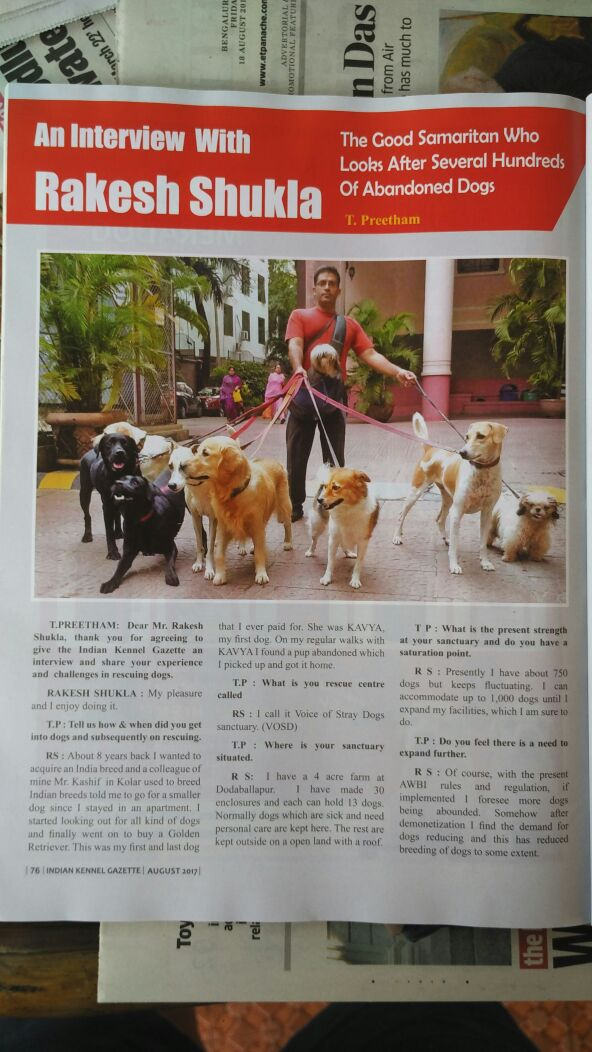What initiatives does Rakesh Shukla mention in the interview to manage the influx and care of the dogs in his sanctuary? Rakesh Shukla mentions several initiatives to manage the influx and care of the dogs at his sanctuary. He talks about the 30 spacious enclosures that can hold 13 dogs each, ensuring that the dogs have ample space to move around. Additionally, he references the open areas available at the farm for the dogs to interact and play. This setup helps in managing the dogs effectively while ensuring their well-being and reducing stress levels. He also discusses the challenge of accommodating up to 1,000 dogs and the continuous need for expansion to keep up with the growing number of rescues. How does Rakesh address the challenges associated with running such a large sanctuary? Rakesh addresses the challenges associated with running the large sanctuary by constantly evaluating and improving the facilities. He acknowledges that the sanctuary has a fluctuating population of around 750 dogs at any given time, which can sometimes go up to 1,000 dogs. To handle this, he ensures that the dogs are well-cared-for by maintaining a spacious and clean environment. Moreover, he hints at the importance of prompt medical care, regular feeding schedules, and a team of dedicated staff and volunteers to look after the dogs. Additionally, he mentions the necessity of expansion to accommodate the increasing number of dogs and to provide them with a better quality of life. What kind of community support or external help does Rakesh Shukla receive for his sanctuary according to the interview? In the interview, Rakesh Shukla does not explicitly mention the details of community support or external help he receives for his sanctuary. However, it can be inferred that running such a large operation likely involves a network of volunteers, donors, and possibly partnerships with local veterinarians and animal welfare organizations. The success of the sanctuary suggests a well-coordinated effort that might include fundraising events, community outreach programs, and collaborations with other animal rescue groups to provide the necessary resources for the dogs' care and wellbeing. 